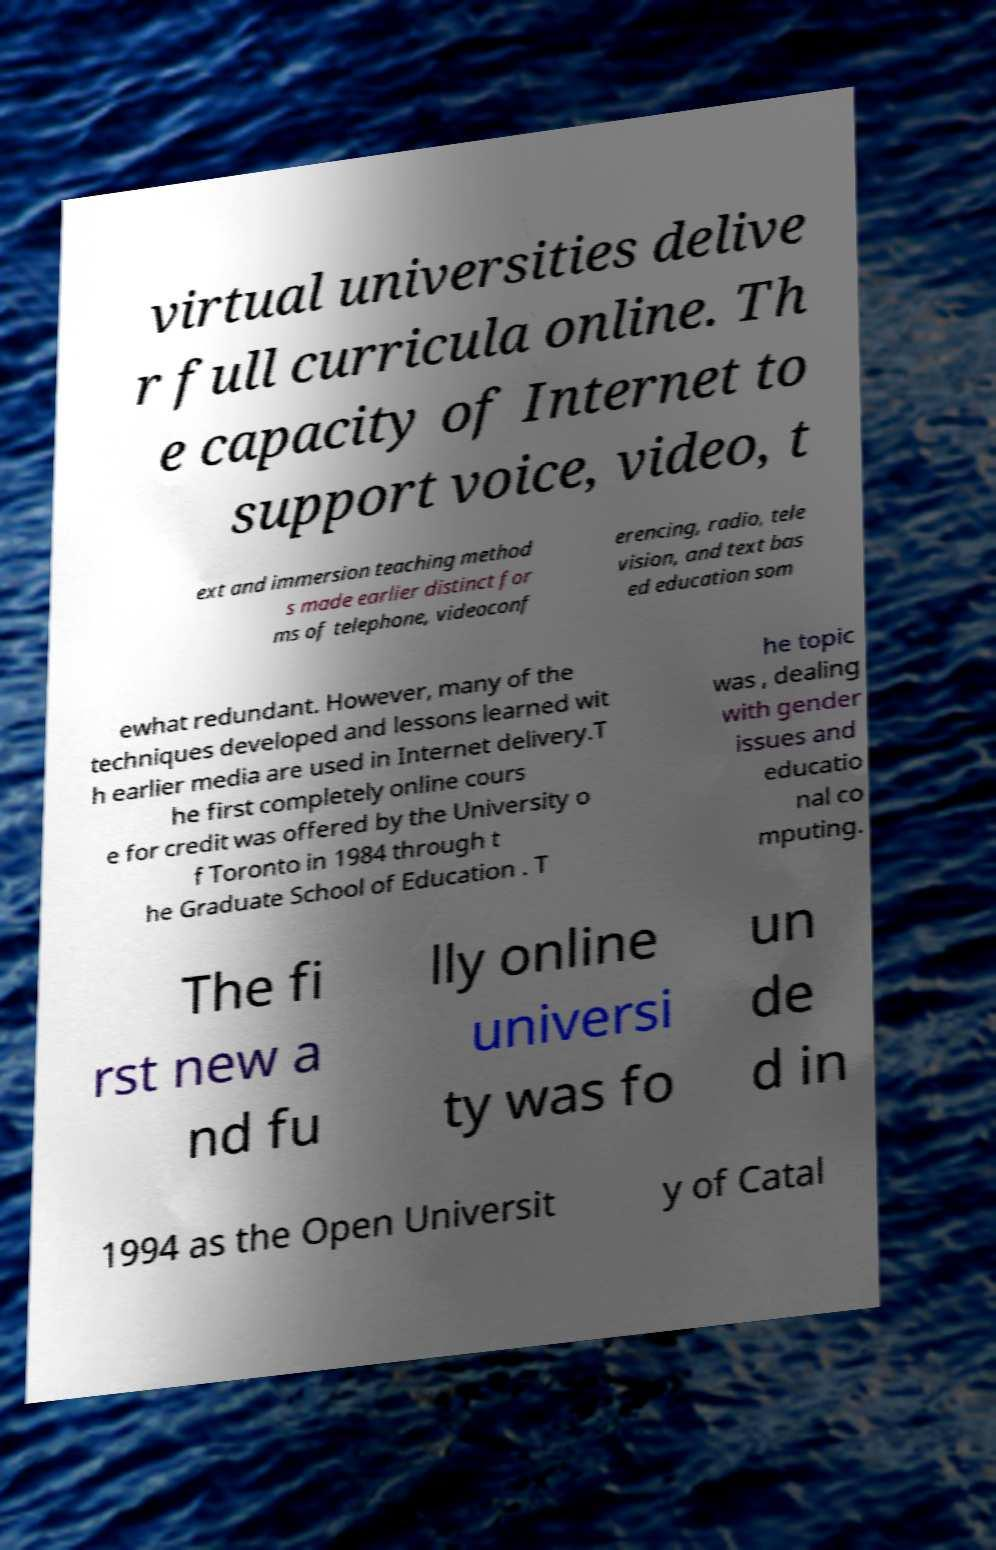Please read and relay the text visible in this image. What does it say? virtual universities delive r full curricula online. Th e capacity of Internet to support voice, video, t ext and immersion teaching method s made earlier distinct for ms of telephone, videoconf erencing, radio, tele vision, and text bas ed education som ewhat redundant. However, many of the techniques developed and lessons learned wit h earlier media are used in Internet delivery.T he first completely online cours e for credit was offered by the University o f Toronto in 1984 through t he Graduate School of Education . T he topic was , dealing with gender issues and educatio nal co mputing. The fi rst new a nd fu lly online universi ty was fo un de d in 1994 as the Open Universit y of Catal 